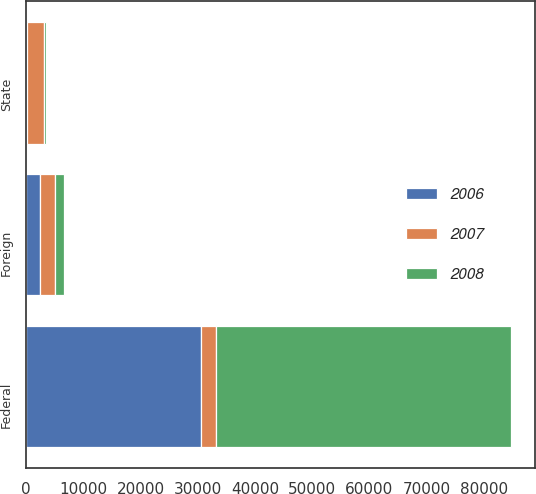Convert chart to OTSL. <chart><loc_0><loc_0><loc_500><loc_500><stacked_bar_chart><ecel><fcel>State<fcel>Foreign<fcel>Federal<nl><fcel>2007<fcel>2974<fcel>2626<fcel>2504.5<nl><fcel>2008<fcel>292<fcel>1685<fcel>51567<nl><fcel>2006<fcel>203<fcel>2383<fcel>30624<nl></chart> 